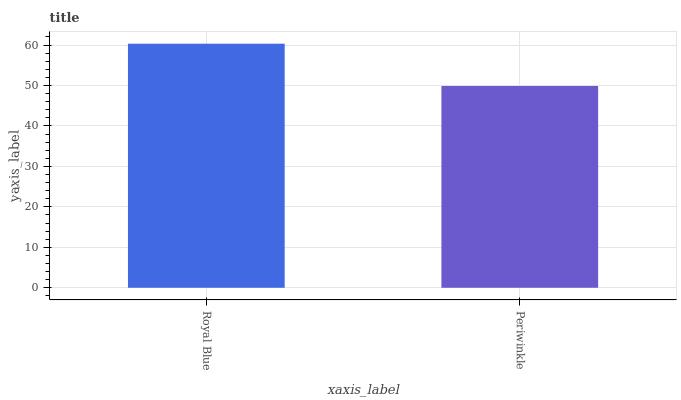Is Periwinkle the maximum?
Answer yes or no. No. Is Royal Blue greater than Periwinkle?
Answer yes or no. Yes. Is Periwinkle less than Royal Blue?
Answer yes or no. Yes. Is Periwinkle greater than Royal Blue?
Answer yes or no. No. Is Royal Blue less than Periwinkle?
Answer yes or no. No. Is Royal Blue the high median?
Answer yes or no. Yes. Is Periwinkle the low median?
Answer yes or no. Yes. Is Periwinkle the high median?
Answer yes or no. No. Is Royal Blue the low median?
Answer yes or no. No. 